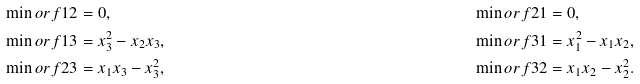<formula> <loc_0><loc_0><loc_500><loc_500>& \min o r { f } { 1 } { 2 } = 0 , & & \min o r { f } { 2 } { 1 } = 0 , \\ & \min o r { f } { 1 } { 3 } = x _ { 3 } ^ { 2 } - x _ { 2 } x _ { 3 } , & & \min o r { f } { 3 } { 1 } = x _ { 1 } ^ { 2 } - x _ { 1 } x _ { 2 } , \\ & \min o r { f } { 2 } { 3 } = x _ { 1 } x _ { 3 } - x _ { 3 } ^ { 2 } , & & \min o r { f } { 3 } { 2 } = x _ { 1 } x _ { 2 } - x _ { 2 } ^ { 2 } .</formula> 